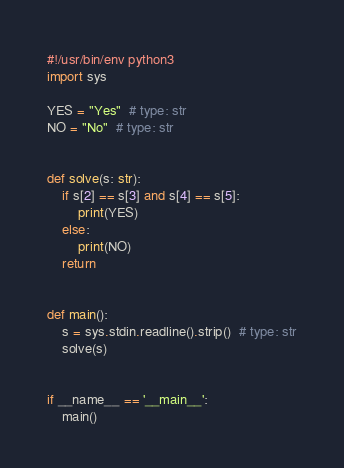Convert code to text. <code><loc_0><loc_0><loc_500><loc_500><_Python_>#!/usr/bin/env python3
import sys

YES = "Yes"  # type: str
NO = "No"  # type: str


def solve(s: str):
    if s[2] == s[3] and s[4] == s[5]:
        print(YES)
    else:
        print(NO)
    return


def main():
    s = sys.stdin.readline().strip()  # type: str
    solve(s)


if __name__ == '__main__':
    main()
</code> 